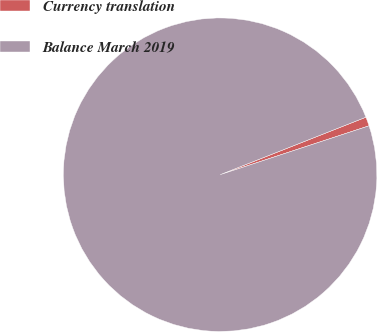Convert chart to OTSL. <chart><loc_0><loc_0><loc_500><loc_500><pie_chart><fcel>Currency translation<fcel>Balance March 2019<nl><fcel>0.93%<fcel>99.07%<nl></chart> 